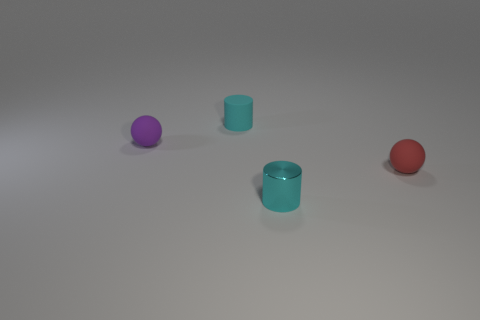There is a small cyan matte thing; how many small cyan matte cylinders are left of it?
Provide a short and direct response. 0. Are there fewer purple matte balls in front of the tiny red rubber thing than small purple rubber things that are on the right side of the cyan rubber cylinder?
Your answer should be very brief. No. What is the shape of the object on the left side of the tiny cyan cylinder that is behind the matte sphere that is in front of the purple ball?
Provide a succinct answer. Sphere. What shape is the tiny object that is behind the cyan shiny thing and on the right side of the cyan rubber cylinder?
Give a very brief answer. Sphere. Are there any other purple things made of the same material as the small purple thing?
Provide a short and direct response. No. What size is the rubber cylinder that is the same color as the metal cylinder?
Keep it short and to the point. Small. There is a small rubber sphere that is left of the small metallic cylinder; what is its color?
Keep it short and to the point. Purple. Is the shape of the purple rubber thing the same as the tiny cyan object behind the small cyan shiny cylinder?
Offer a terse response. No. Are there any tiny matte things that have the same color as the small shiny thing?
Your response must be concise. Yes. There is a cylinder that is made of the same material as the purple object; what size is it?
Give a very brief answer. Small. 